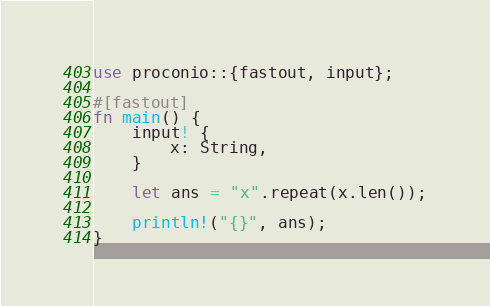Convert code to text. <code><loc_0><loc_0><loc_500><loc_500><_Rust_>use proconio::{fastout, input};

#[fastout]
fn main() {
    input! {
        x: String,
    }

    let ans = "x".repeat(x.len());

    println!("{}", ans);
}
</code> 